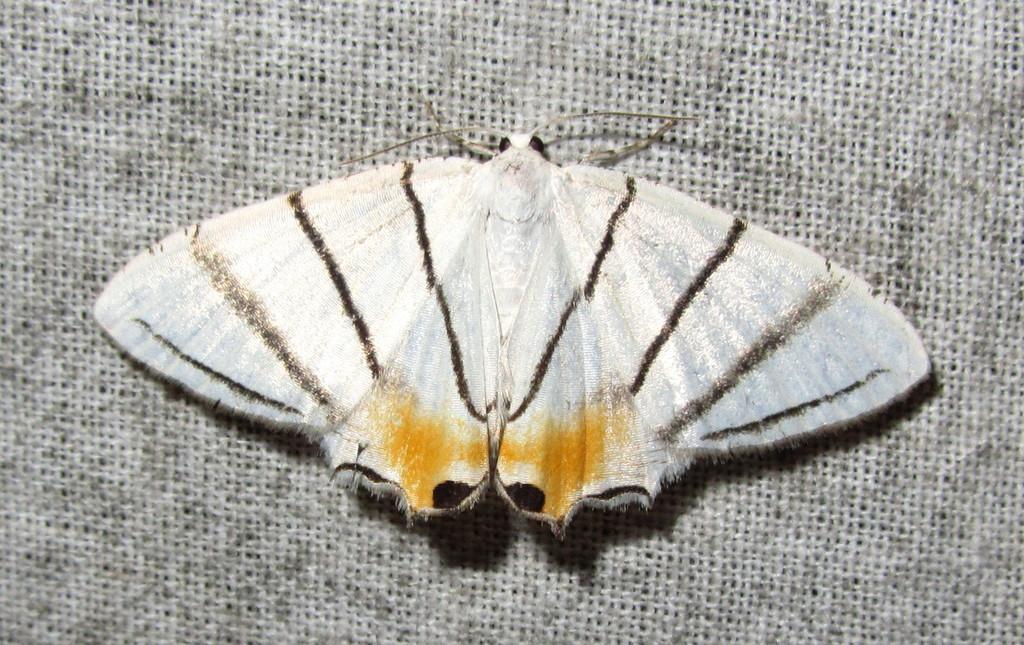Can you describe this image briefly? We can see insect on surface. 